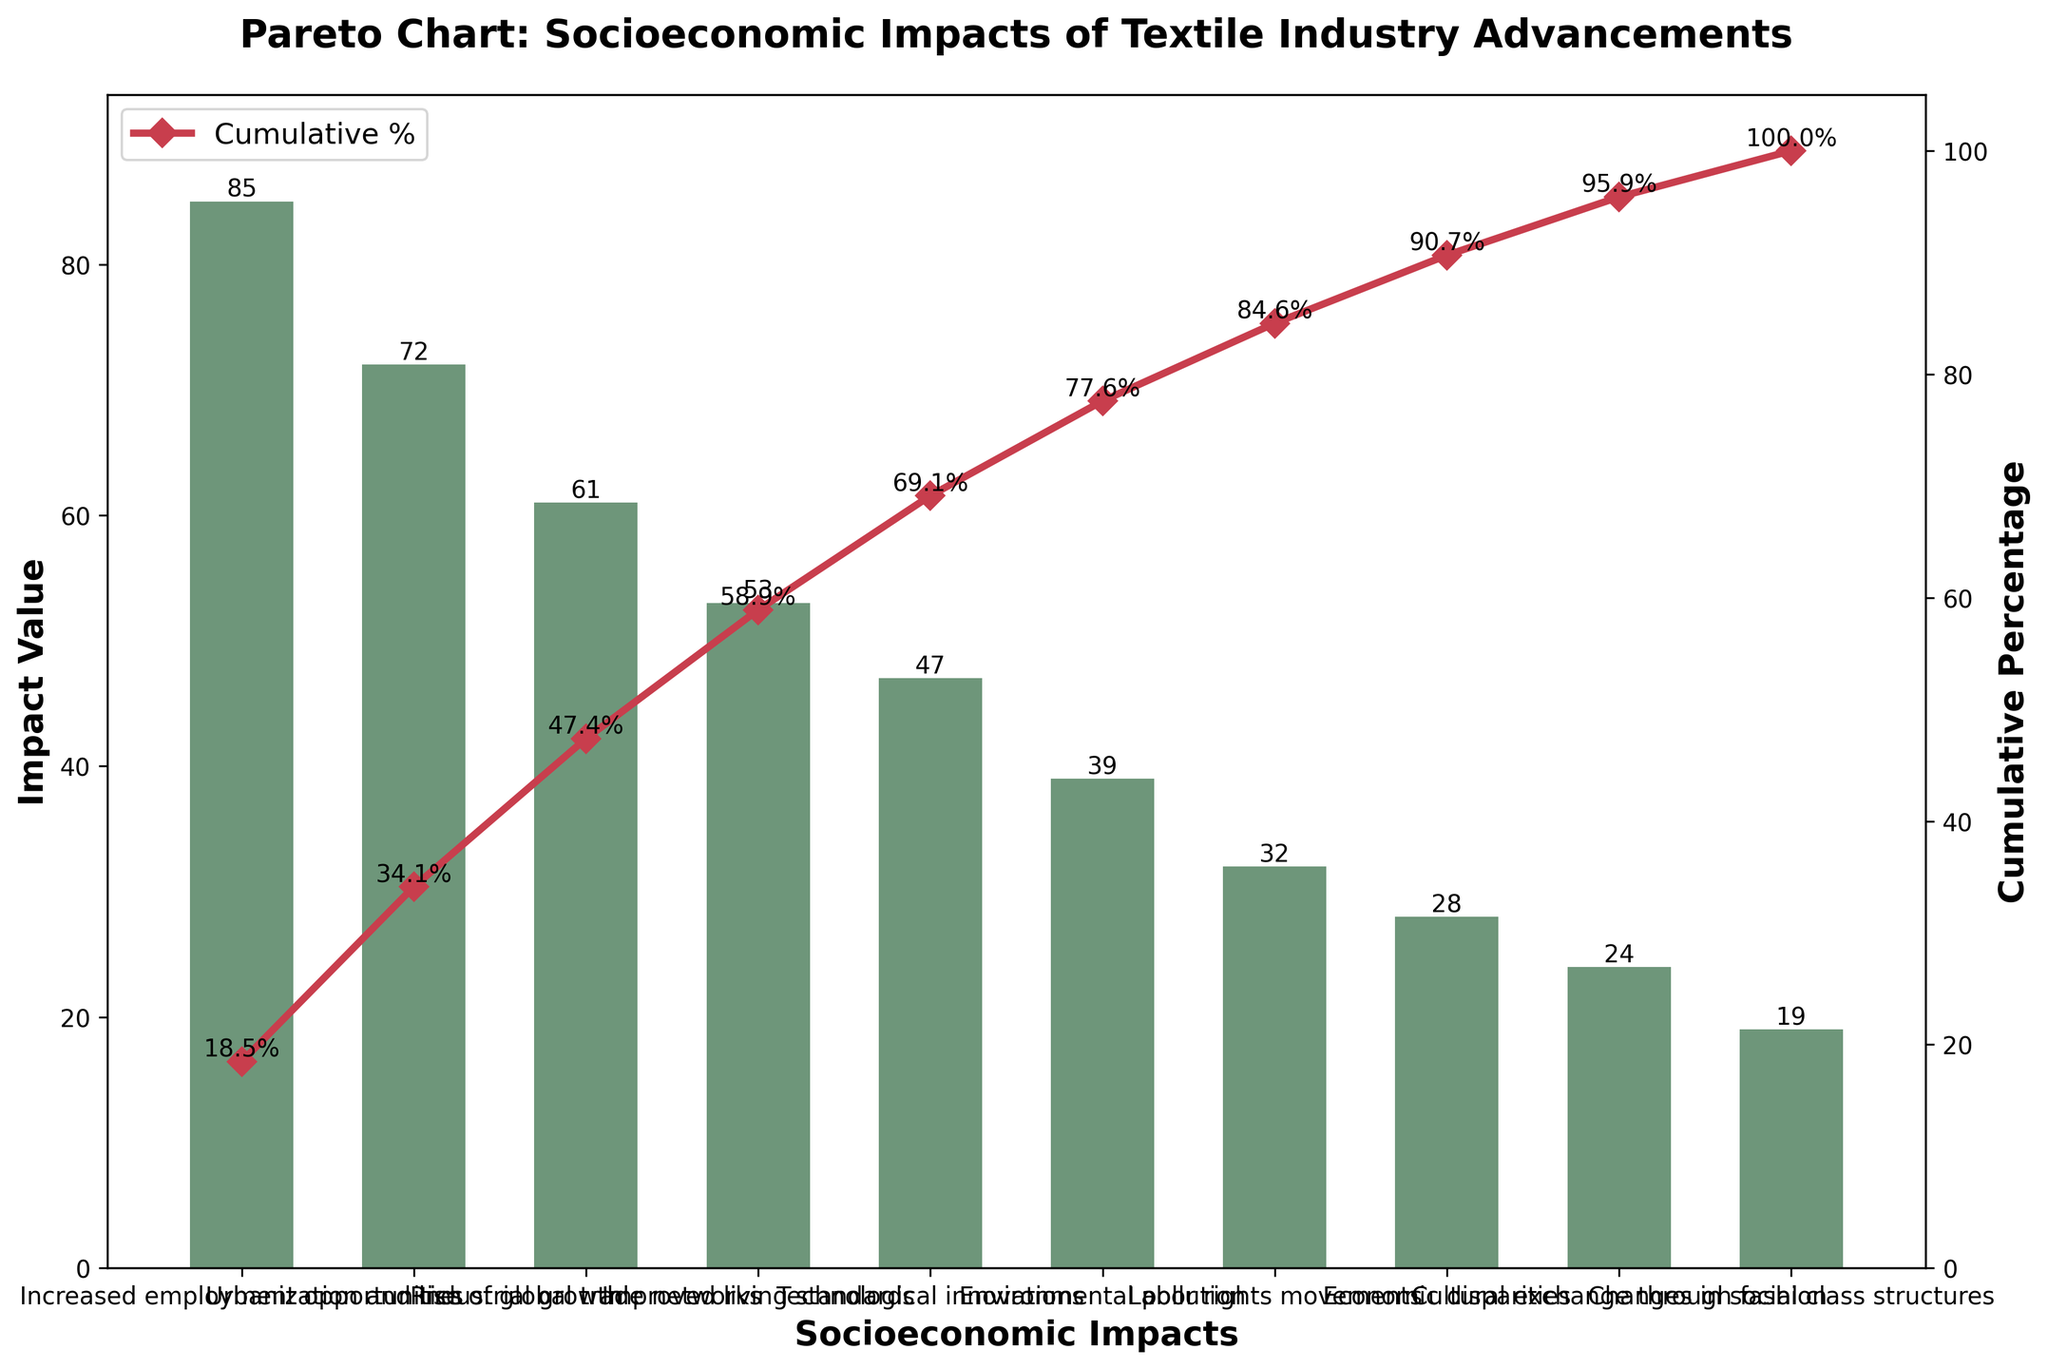What is the highest-ranked socioeconomic impact of textile industry advancements? The highest-ranked impact is the one with the largest value. Referring to the figure, "Increased employment opportunities" has the highest impact value of 85.
Answer: Increased employment opportunities What is the approximate cumulative percentage for "Improved living standards"? To find the cumulative percentage for "Improved living standards," we look for the corresponding value on the cumulative percentage line in the figure. It is approximately 68%.
Answer: 68% What is the difference in impact values between "Urbanization and industrial growth" and "Economic disparities"? The impact value for "Urbanization and industrial growth" is 72, and for "Economic disparities," it is 28. The difference is 72 - 28 = 44.
Answer: 44 Which impact is responsible for reaching roughly 50% of the cumulative percentage? To determine which impact corresponds to the 50% mark on the cumulative percentage line, locate the point on the cumulative percentage line that is closest to 50%. "Urbanization and industrial growth" corresponds to approximately the 51.4% mark.
Answer: Urbanization and industrial growth Are there more impacts with impact values above or below 40? Count the number of impacts with values greater than 40 and those with values less than 40. There are 5 impacts above 40 and 5 impacts below 40. Therefore, the numbers are equal.
Answer: Equal Which socioeconomic impact is ranked just below "Technological innovations"? The impact ranked just below "Technological innovations," which has a value of 47, is "Environmental pollution" with a value of 39.
Answer: Environmental pollution Why does the cumulative percentage continue to rise even after smaller impacts? The cumulative percentage line aggregates the values of all impacts, regardless of their individual values. Thus, even smaller impacts contribute to the overall cumulative percentage, which continually rises and eventually reaches 100%.
Answer: Smaller impacts contribute to the cumulative percentage How does the socioeconomic impact value of "Cultural exchange through fashion" compare to "Labor rights movements"? The impact value for "Cultural exchange through fashion" is 24, whereas for "Labor rights movements," it is 32. Hence, "Cultural exchange through fashion" has a lower impact value than "Labor rights movements."
Answer: Lower What is the total cumulative percentage reached by considering the top three socioeconomic impacts? The top three impacts are "Increased employment opportunities" (85), "Urbanization and industrial growth" (72), and "Rise of global trade networks" (61). Their cumulative percentages are approximately 33.8%, 58.3%, and 82.5%, respectively. Summing these up: 33.8 + 58.3 + 82.5 = 174.6%, but it's the cumulative percentage for these impacts combined. The value is roughly 82.5% from the figure.
Answer: 82.5% 